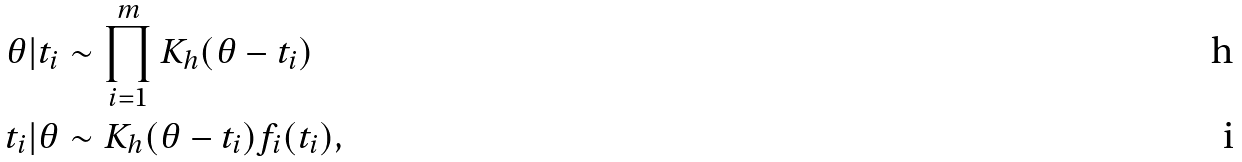<formula> <loc_0><loc_0><loc_500><loc_500>\theta | t _ { i } & \sim \prod _ { i = 1 } ^ { m } K _ { h } ( \theta - t _ { i } ) \\ t _ { i } | \theta & \sim K _ { h } ( \theta - t _ { i } ) f _ { i } ( t _ { i } ) ,</formula> 